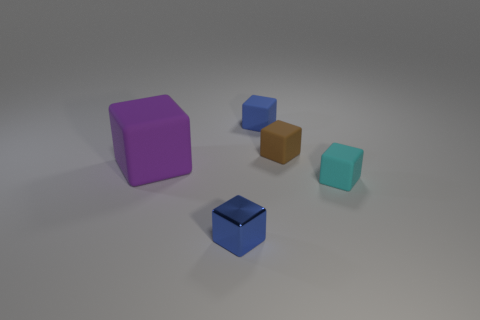What number of small rubber things are the same color as the shiny block?
Your answer should be compact. 1. Is the number of brown blocks that are to the right of the blue metal object less than the number of blocks to the right of the big purple cube?
Provide a short and direct response. Yes. What is the size of the thing left of the blue metallic block?
Ensure brevity in your answer.  Large. Are there any tiny objects made of the same material as the big purple block?
Offer a terse response. Yes. There is a metallic cube that is the same size as the cyan thing; what is its color?
Offer a very short reply. Blue. How many other things are there of the same shape as the tiny brown rubber object?
Provide a succinct answer. 4. Is the size of the blue metallic block the same as the blue object that is behind the small brown thing?
Keep it short and to the point. Yes. What number of things are either big gray metallic things or blocks?
Offer a terse response. 5. How many other things are there of the same size as the cyan rubber block?
Your answer should be very brief. 3. Is the color of the small metallic thing the same as the cube that is behind the tiny brown matte block?
Offer a very short reply. Yes. 